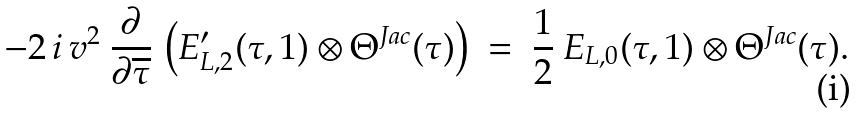<formula> <loc_0><loc_0><loc_500><loc_500>- 2 \, i \, v ^ { 2 } \ \frac { \partial } { \partial \overline { \tau } } \, \left ( E ^ { \prime } _ { L , 2 } ( \tau , 1 ) \otimes \Theta ^ { J a c } ( \tau ) \right ) \ = \ \frac { 1 } { 2 } \ E _ { L , 0 } ( \tau , 1 ) \otimes \Theta ^ { J a c } ( \tau ) .</formula> 